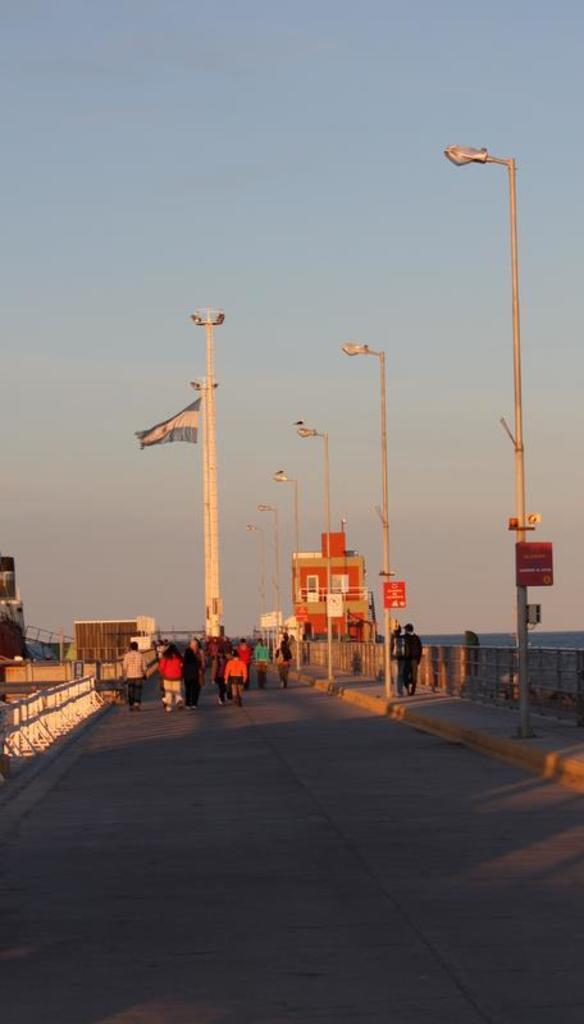Describe this image in one or two sentences. In this picture I can see there is a bridge and there are few people walking on the bridge, few are walking on the walkway. There are a few poles with lights and there is a pole in the backdrop with a flag. There is a building and the sky is clear. 